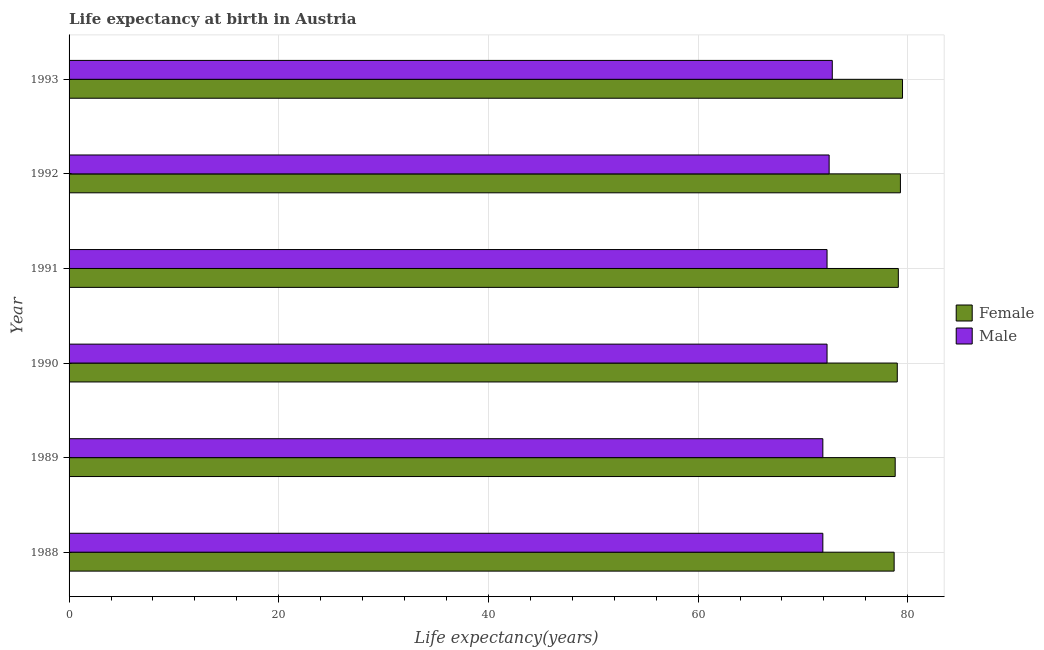How many different coloured bars are there?
Provide a succinct answer. 2. How many groups of bars are there?
Offer a very short reply. 6. Are the number of bars on each tick of the Y-axis equal?
Offer a terse response. Yes. How many bars are there on the 3rd tick from the top?
Your answer should be compact. 2. What is the life expectancy(female) in 1990?
Offer a very short reply. 79. Across all years, what is the maximum life expectancy(male)?
Provide a succinct answer. 72.8. Across all years, what is the minimum life expectancy(male)?
Your answer should be compact. 71.9. In which year was the life expectancy(male) maximum?
Keep it short and to the point. 1993. What is the total life expectancy(female) in the graph?
Your response must be concise. 474.4. What is the difference between the life expectancy(male) in 1989 and that in 1990?
Ensure brevity in your answer.  -0.4. What is the difference between the life expectancy(male) in 1993 and the life expectancy(female) in 1991?
Make the answer very short. -6.3. What is the average life expectancy(female) per year?
Your response must be concise. 79.07. In how many years, is the life expectancy(male) greater than 24 years?
Your answer should be compact. 6. Is the life expectancy(male) in 1988 less than that in 1990?
Keep it short and to the point. Yes. Is the difference between the life expectancy(female) in 1989 and 1990 greater than the difference between the life expectancy(male) in 1989 and 1990?
Offer a very short reply. Yes. In how many years, is the life expectancy(female) greater than the average life expectancy(female) taken over all years?
Offer a very short reply. 3. Is the sum of the life expectancy(female) in 1988 and 1990 greater than the maximum life expectancy(male) across all years?
Give a very brief answer. Yes. What does the 1st bar from the top in 1993 represents?
Make the answer very short. Male. How many bars are there?
Keep it short and to the point. 12. How many years are there in the graph?
Provide a short and direct response. 6. Does the graph contain grids?
Your answer should be very brief. Yes. How are the legend labels stacked?
Provide a succinct answer. Vertical. What is the title of the graph?
Keep it short and to the point. Life expectancy at birth in Austria. What is the label or title of the X-axis?
Your answer should be compact. Life expectancy(years). What is the label or title of the Y-axis?
Make the answer very short. Year. What is the Life expectancy(years) of Female in 1988?
Your response must be concise. 78.7. What is the Life expectancy(years) of Male in 1988?
Provide a succinct answer. 71.9. What is the Life expectancy(years) in Female in 1989?
Give a very brief answer. 78.8. What is the Life expectancy(years) in Male in 1989?
Provide a short and direct response. 71.9. What is the Life expectancy(years) in Female in 1990?
Provide a succinct answer. 79. What is the Life expectancy(years) of Male in 1990?
Offer a very short reply. 72.3. What is the Life expectancy(years) in Female in 1991?
Your answer should be very brief. 79.1. What is the Life expectancy(years) in Male in 1991?
Provide a succinct answer. 72.3. What is the Life expectancy(years) of Female in 1992?
Offer a very short reply. 79.3. What is the Life expectancy(years) in Male in 1992?
Your response must be concise. 72.5. What is the Life expectancy(years) in Female in 1993?
Keep it short and to the point. 79.5. What is the Life expectancy(years) in Male in 1993?
Ensure brevity in your answer.  72.8. Across all years, what is the maximum Life expectancy(years) in Female?
Offer a terse response. 79.5. Across all years, what is the maximum Life expectancy(years) of Male?
Your response must be concise. 72.8. Across all years, what is the minimum Life expectancy(years) in Female?
Offer a very short reply. 78.7. Across all years, what is the minimum Life expectancy(years) of Male?
Keep it short and to the point. 71.9. What is the total Life expectancy(years) of Female in the graph?
Give a very brief answer. 474.4. What is the total Life expectancy(years) in Male in the graph?
Provide a succinct answer. 433.7. What is the difference between the Life expectancy(years) of Female in 1988 and that in 1990?
Your answer should be very brief. -0.3. What is the difference between the Life expectancy(years) in Male in 1988 and that in 1990?
Offer a very short reply. -0.4. What is the difference between the Life expectancy(years) of Male in 1988 and that in 1991?
Offer a terse response. -0.4. What is the difference between the Life expectancy(years) in Female in 1988 and that in 1992?
Provide a succinct answer. -0.6. What is the difference between the Life expectancy(years) in Female in 1988 and that in 1993?
Your response must be concise. -0.8. What is the difference between the Life expectancy(years) in Female in 1989 and that in 1990?
Ensure brevity in your answer.  -0.2. What is the difference between the Life expectancy(years) in Female in 1989 and that in 1991?
Offer a terse response. -0.3. What is the difference between the Life expectancy(years) in Male in 1989 and that in 1991?
Keep it short and to the point. -0.4. What is the difference between the Life expectancy(years) in Male in 1989 and that in 1992?
Give a very brief answer. -0.6. What is the difference between the Life expectancy(years) in Male in 1990 and that in 1991?
Your response must be concise. 0. What is the difference between the Life expectancy(years) in Female in 1990 and that in 1992?
Offer a very short reply. -0.3. What is the difference between the Life expectancy(years) of Female in 1991 and that in 1993?
Provide a short and direct response. -0.4. What is the difference between the Life expectancy(years) of Female in 1988 and the Life expectancy(years) of Male in 1989?
Keep it short and to the point. 6.8. What is the difference between the Life expectancy(years) in Female in 1988 and the Life expectancy(years) in Male in 1990?
Keep it short and to the point. 6.4. What is the difference between the Life expectancy(years) of Female in 1988 and the Life expectancy(years) of Male in 1992?
Offer a very short reply. 6.2. What is the difference between the Life expectancy(years) in Female in 1988 and the Life expectancy(years) in Male in 1993?
Give a very brief answer. 5.9. What is the difference between the Life expectancy(years) of Female in 1989 and the Life expectancy(years) of Male in 1990?
Your answer should be compact. 6.5. What is the difference between the Life expectancy(years) of Female in 1989 and the Life expectancy(years) of Male in 1993?
Provide a short and direct response. 6. What is the difference between the Life expectancy(years) in Female in 1990 and the Life expectancy(years) in Male in 1991?
Keep it short and to the point. 6.7. What is the difference between the Life expectancy(years) in Female in 1990 and the Life expectancy(years) in Male in 1992?
Offer a very short reply. 6.5. What is the average Life expectancy(years) in Female per year?
Offer a terse response. 79.07. What is the average Life expectancy(years) in Male per year?
Make the answer very short. 72.28. In the year 1988, what is the difference between the Life expectancy(years) in Female and Life expectancy(years) in Male?
Provide a succinct answer. 6.8. In the year 1990, what is the difference between the Life expectancy(years) in Female and Life expectancy(years) in Male?
Give a very brief answer. 6.7. In the year 1991, what is the difference between the Life expectancy(years) of Female and Life expectancy(years) of Male?
Your response must be concise. 6.8. What is the ratio of the Life expectancy(years) of Female in 1988 to that in 1989?
Make the answer very short. 1. What is the ratio of the Life expectancy(years) in Male in 1988 to that in 1989?
Provide a short and direct response. 1. What is the ratio of the Life expectancy(years) in Female in 1988 to that in 1990?
Offer a terse response. 1. What is the ratio of the Life expectancy(years) in Male in 1988 to that in 1990?
Make the answer very short. 0.99. What is the ratio of the Life expectancy(years) in Male in 1988 to that in 1991?
Provide a succinct answer. 0.99. What is the ratio of the Life expectancy(years) in Female in 1988 to that in 1992?
Give a very brief answer. 0.99. What is the ratio of the Life expectancy(years) in Male in 1988 to that in 1992?
Offer a very short reply. 0.99. What is the ratio of the Life expectancy(years) in Male in 1988 to that in 1993?
Keep it short and to the point. 0.99. What is the ratio of the Life expectancy(years) of Male in 1989 to that in 1990?
Your answer should be compact. 0.99. What is the ratio of the Life expectancy(years) in Female in 1989 to that in 1992?
Make the answer very short. 0.99. What is the ratio of the Life expectancy(years) in Female in 1989 to that in 1993?
Your response must be concise. 0.99. What is the ratio of the Life expectancy(years) of Male in 1989 to that in 1993?
Provide a short and direct response. 0.99. What is the ratio of the Life expectancy(years) of Female in 1990 to that in 1991?
Your response must be concise. 1. What is the ratio of the Life expectancy(years) of Female in 1990 to that in 1993?
Your answer should be compact. 0.99. What is the ratio of the Life expectancy(years) in Female in 1992 to that in 1993?
Ensure brevity in your answer.  1. What is the difference between the highest and the second highest Life expectancy(years) in Female?
Ensure brevity in your answer.  0.2. What is the difference between the highest and the lowest Life expectancy(years) of Female?
Your answer should be very brief. 0.8. What is the difference between the highest and the lowest Life expectancy(years) of Male?
Keep it short and to the point. 0.9. 